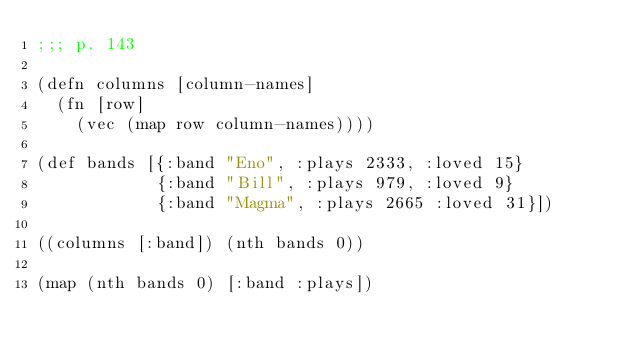Convert code to text. <code><loc_0><loc_0><loc_500><loc_500><_Clojure_>;;; p. 143

(defn columns [column-names]
  (fn [row]
    (vec (map row column-names))))

(def bands [{:band "Eno", :plays 2333, :loved 15}
            {:band "Bill", :plays 979, :loved 9}
            {:band "Magma", :plays 2665 :loved 31}])

((columns [:band]) (nth bands 0))

(map (nth bands 0) [:band :plays])
</code> 